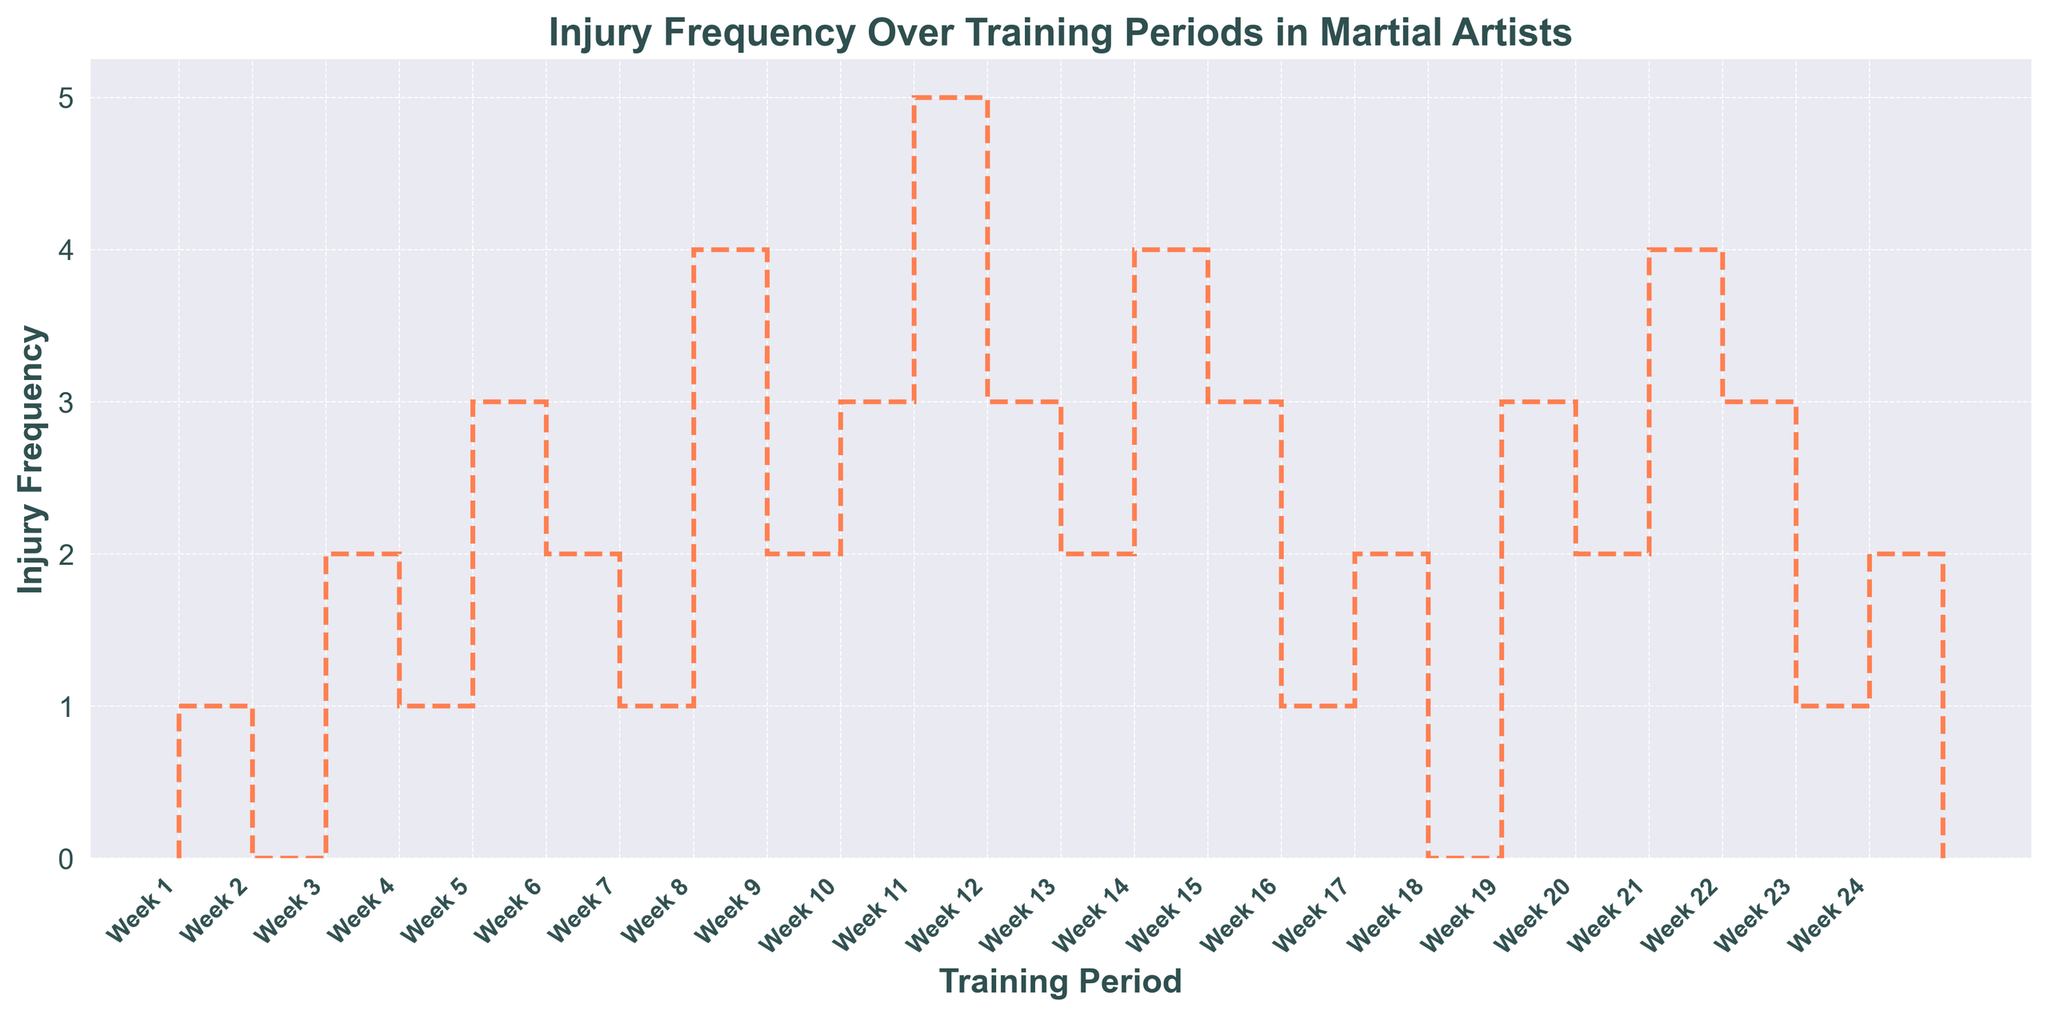What's the training period with the highest injury frequency? To find the training period with the highest injury frequency, scan the plot for the tallest stair step. The highest point is at Week 11 with an injury frequency of 5.
Answer: Week 11 What's the average injury frequency over the 24 weeks? Sum the injury frequencies over the 24 weeks and divide by the number of weeks. The sum is 59 (1+0+2+1+3+2+1+4+2+3+5+3+2+4+3+1+2+0+3+2+4+3+1+2 = 59) and the number of weeks is 24. The average is 59/24 ≈ 2.46.
Answer: 2.46 During which weeks do the injury frequencies remain consistent and unchanged? Identify periods in the plot where the stair steps remain flat. This occurs from Week 1 to Week 2, and Week 18 to Week 19.
Answer: Week 1-2, Week 18-19 How does the injury frequency in Week 4 compare to Week 5? Look at the heights of the stair steps in Weeks 4 and 5. Week 4 has 1 injury, while Week 5 has 3 injuries. Week 5 has more injuries than Week 4.
Answer: Week 5 What is the median injury frequency over the training period? Arrange injury frequencies in ascending order and find the middle value. The ordered frequencies are 0, 0, 1, 1, 1, 1, 1, 2, 2, 2, 2, 2, 2, 3, 3, 3, 3, 3, 3, 4, 4, 4, 4, 5. The median is the average of the 12th and 13th values: (2+2)/2 = 2.
Answer: 2 How many weeks had an injury frequency of 4 or more? Count the number of stair steps that reach a height of 4 or more. The weeks are Week 8, Week 11, Week 14, and Week 21.
Answer: 4 weeks During which week does the injury frequency first reach 3? Identify the first stair step that reaches a height of 3. This occurs in Week 5.
Answer: Week 5 Which training period had no injuries? Locate the stair steps at a height of 0 in the plot. This occurs in Week 2 and Week 18.
Answer: Week 2, Week 18 